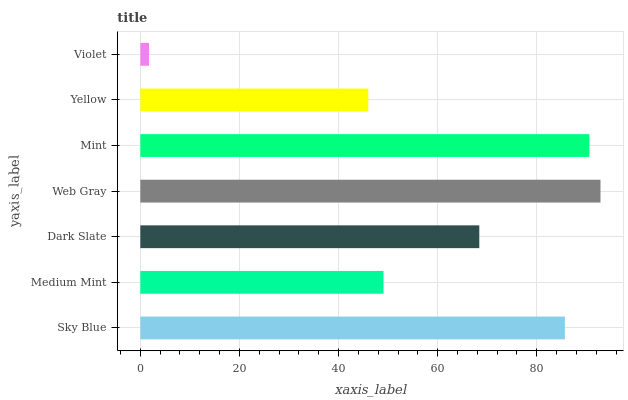Is Violet the minimum?
Answer yes or no. Yes. Is Web Gray the maximum?
Answer yes or no. Yes. Is Medium Mint the minimum?
Answer yes or no. No. Is Medium Mint the maximum?
Answer yes or no. No. Is Sky Blue greater than Medium Mint?
Answer yes or no. Yes. Is Medium Mint less than Sky Blue?
Answer yes or no. Yes. Is Medium Mint greater than Sky Blue?
Answer yes or no. No. Is Sky Blue less than Medium Mint?
Answer yes or no. No. Is Dark Slate the high median?
Answer yes or no. Yes. Is Dark Slate the low median?
Answer yes or no. Yes. Is Mint the high median?
Answer yes or no. No. Is Mint the low median?
Answer yes or no. No. 